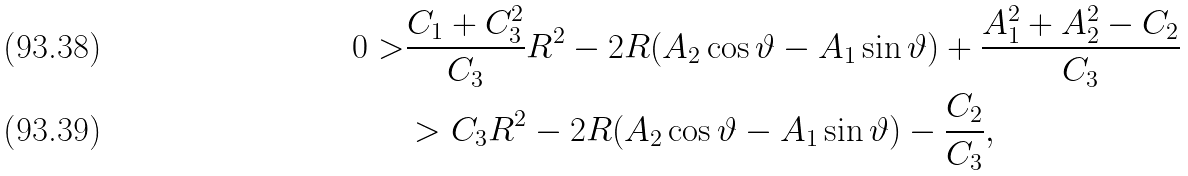<formula> <loc_0><loc_0><loc_500><loc_500>0 > & \frac { C _ { 1 } + C _ { 3 } ^ { 2 } } { C _ { 3 } } R ^ { 2 } - 2 R ( A _ { 2 } \cos \vartheta - A _ { 1 } \sin \vartheta ) + \frac { A _ { 1 } ^ { 2 } + A _ { 2 } ^ { 2 } - C _ { 2 } } { C _ { 3 } } \\ & > C _ { 3 } R ^ { 2 } - 2 R ( A _ { 2 } \cos \vartheta - A _ { 1 } \sin \vartheta ) - \frac { C _ { 2 } } { C _ { 3 } } ,</formula> 